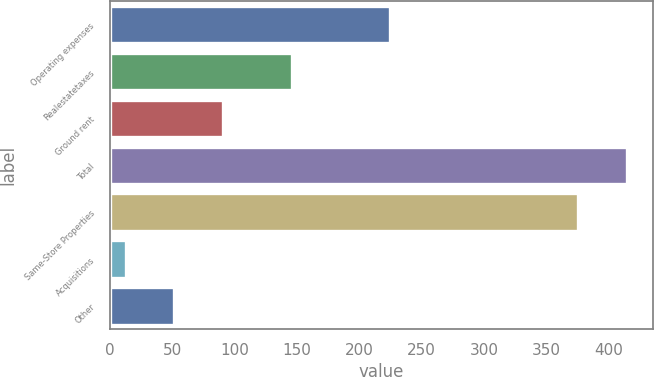Convert chart to OTSL. <chart><loc_0><loc_0><loc_500><loc_500><bar_chart><fcel>Operating expenses<fcel>Realestatetaxes<fcel>Ground rent<fcel>Total<fcel>Same-Store Properties<fcel>Acquisitions<fcel>Other<nl><fcel>224.7<fcel>145.8<fcel>90.58<fcel>414.49<fcel>375.6<fcel>12.8<fcel>51.69<nl></chart> 